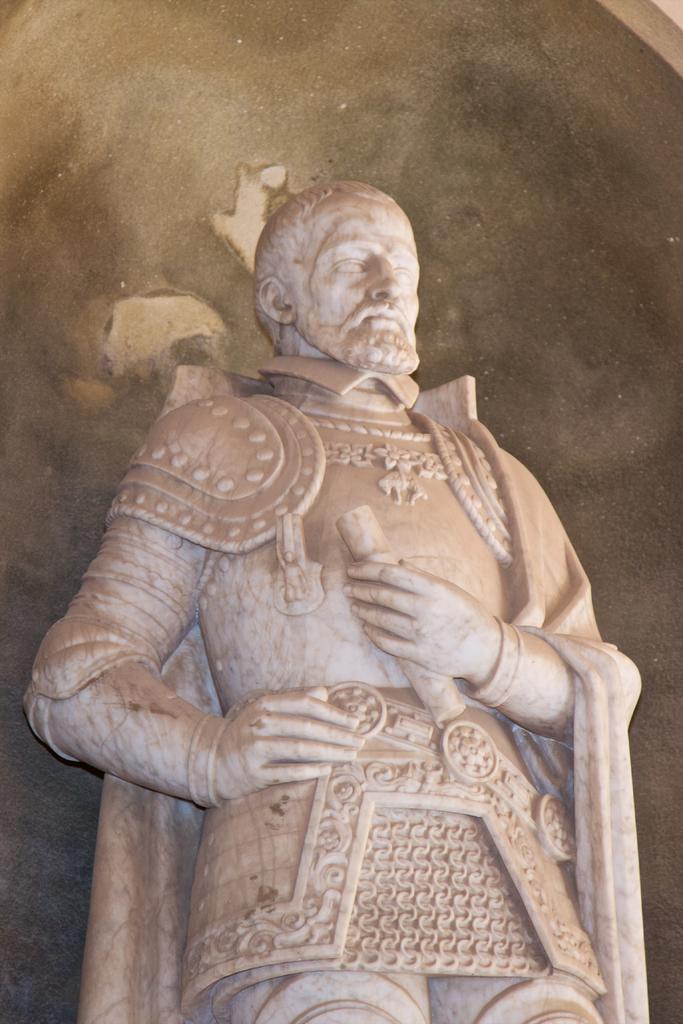How would you summarize this image in a sentence or two? In this image, in the middle, we can see a statue. In the background, we can see black color. 